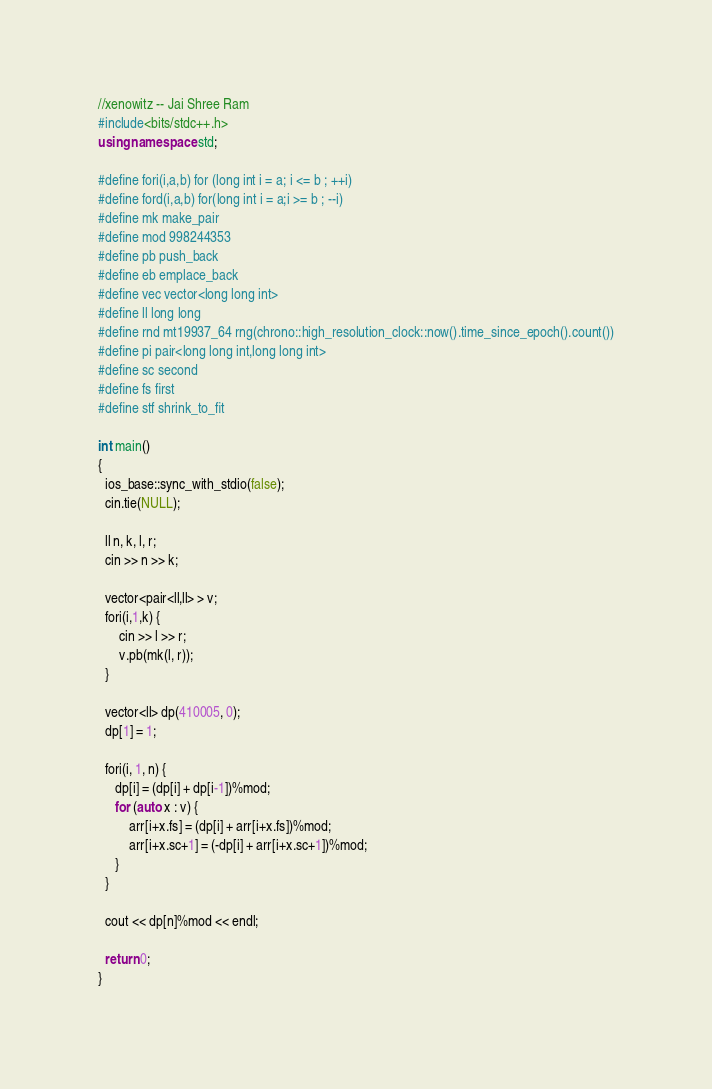<code> <loc_0><loc_0><loc_500><loc_500><_C++_>//xenowitz -- Jai Shree Ram
#include<bits/stdc++.h>
using namespace std;

#define fori(i,a,b) for (long int i = a; i <= b ; ++i)
#define ford(i,a,b) for(long int i = a;i >= b ; --i)
#define mk make_pair
#define mod 998244353
#define pb push_back
#define eb emplace_back
#define vec vector<long long int>
#define ll long long
#define rnd mt19937_64 rng(chrono::high_resolution_clock::now().time_since_epoch().count())
#define pi pair<long long int,long long int>
#define sc second
#define fs first
#define stf shrink_to_fit

int main()
{
  ios_base::sync_with_stdio(false);
  cin.tie(NULL);

  ll n, k, l, r;
  cin >> n >> k;

  vector<pair<ll,ll> > v;
  fori(i,1,k) {
      cin >> l >> r;
      v.pb(mk(l, r));
  }

  vector<ll> dp(410005, 0);
  dp[1] = 1;

  fori(i, 1, n) {
     dp[i] = (dp[i] + dp[i-1])%mod;
     for (auto x : v) {
         arr[i+x.fs] = (dp[i] + arr[i+x.fs])%mod;
         arr[i+x.sc+1] = (-dp[i] + arr[i+x.sc+1])%mod;
     }
  }

  cout << dp[n]%mod << endl;

  return 0;
}
</code> 